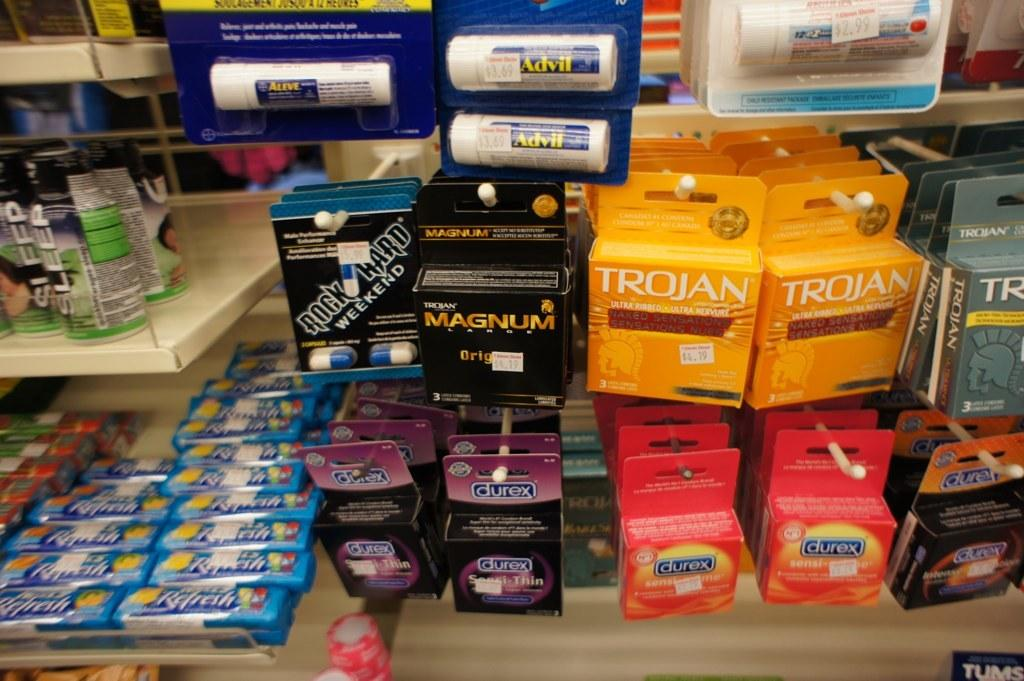<image>
Render a clear and concise summary of the photo. an aisle in a store with some boxes of trojan condums on it 